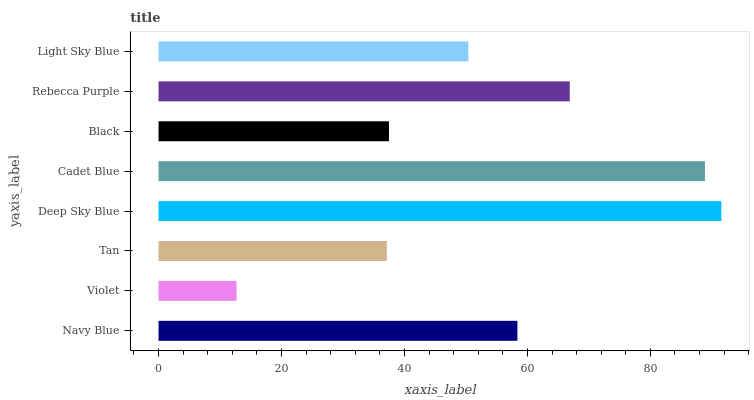Is Violet the minimum?
Answer yes or no. Yes. Is Deep Sky Blue the maximum?
Answer yes or no. Yes. Is Tan the minimum?
Answer yes or no. No. Is Tan the maximum?
Answer yes or no. No. Is Tan greater than Violet?
Answer yes or no. Yes. Is Violet less than Tan?
Answer yes or no. Yes. Is Violet greater than Tan?
Answer yes or no. No. Is Tan less than Violet?
Answer yes or no. No. Is Navy Blue the high median?
Answer yes or no. Yes. Is Light Sky Blue the low median?
Answer yes or no. Yes. Is Black the high median?
Answer yes or no. No. Is Rebecca Purple the low median?
Answer yes or no. No. 